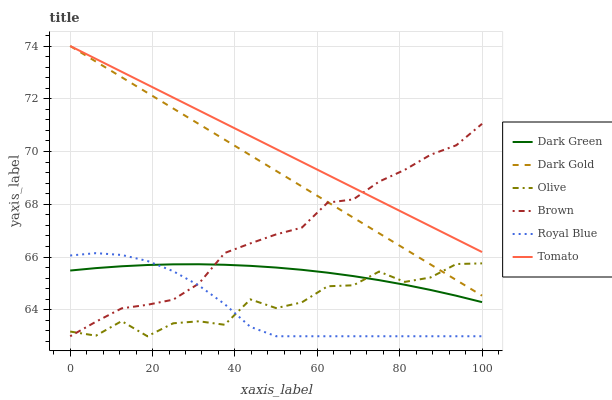Does Royal Blue have the minimum area under the curve?
Answer yes or no. Yes. Does Tomato have the maximum area under the curve?
Answer yes or no. Yes. Does Brown have the minimum area under the curve?
Answer yes or no. No. Does Brown have the maximum area under the curve?
Answer yes or no. No. Is Dark Gold the smoothest?
Answer yes or no. Yes. Is Olive the roughest?
Answer yes or no. Yes. Is Brown the smoothest?
Answer yes or no. No. Is Brown the roughest?
Answer yes or no. No. Does Brown have the lowest value?
Answer yes or no. Yes. Does Dark Gold have the lowest value?
Answer yes or no. No. Does Dark Gold have the highest value?
Answer yes or no. Yes. Does Brown have the highest value?
Answer yes or no. No. Is Royal Blue less than Tomato?
Answer yes or no. Yes. Is Dark Gold greater than Royal Blue?
Answer yes or no. Yes. Does Olive intersect Royal Blue?
Answer yes or no. Yes. Is Olive less than Royal Blue?
Answer yes or no. No. Is Olive greater than Royal Blue?
Answer yes or no. No. Does Royal Blue intersect Tomato?
Answer yes or no. No. 